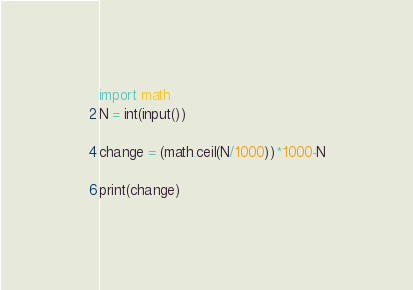Convert code to text. <code><loc_0><loc_0><loc_500><loc_500><_Python_>import math
N = int(input())

change = (math.ceil(N/1000))*1000-N

print(change)</code> 